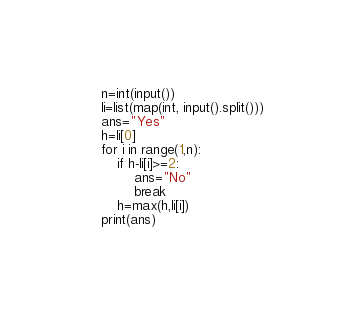Convert code to text. <code><loc_0><loc_0><loc_500><loc_500><_Python_>n=int(input())
li=list(map(int, input().split()))
ans="Yes"
h=li[0]
for i in range(1,n):
    if h-li[i]>=2:
        ans="No"
        break
    h=max(h,li[i])
print(ans)</code> 